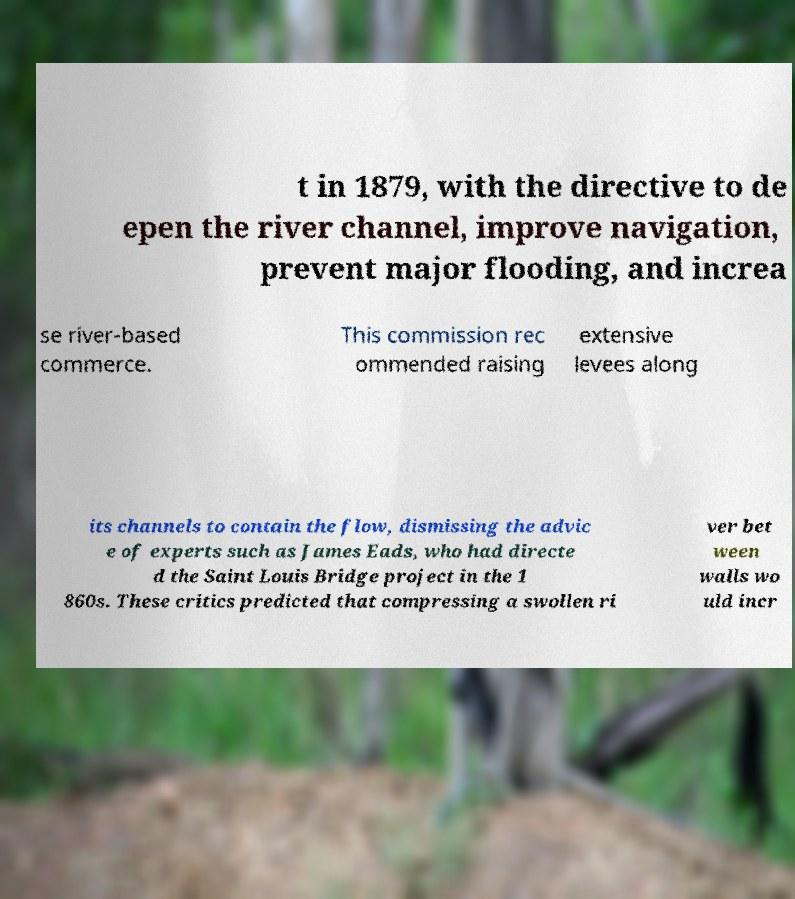Can you accurately transcribe the text from the provided image for me? t in 1879, with the directive to de epen the river channel, improve navigation, prevent major flooding, and increa se river-based commerce. This commission rec ommended raising extensive levees along its channels to contain the flow, dismissing the advic e of experts such as James Eads, who had directe d the Saint Louis Bridge project in the 1 860s. These critics predicted that compressing a swollen ri ver bet ween walls wo uld incr 